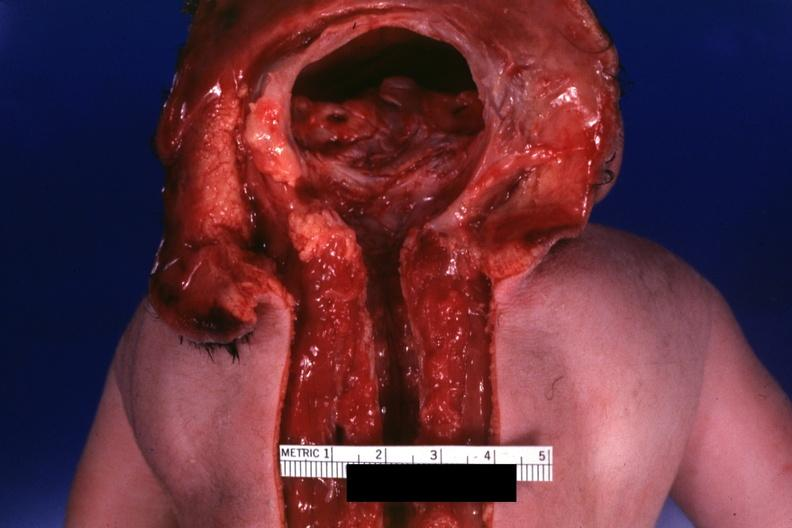does this image show dysraphism encephalocele occipital premature female no chromosomal defects lived one day?
Answer the question using a single word or phrase. Yes 